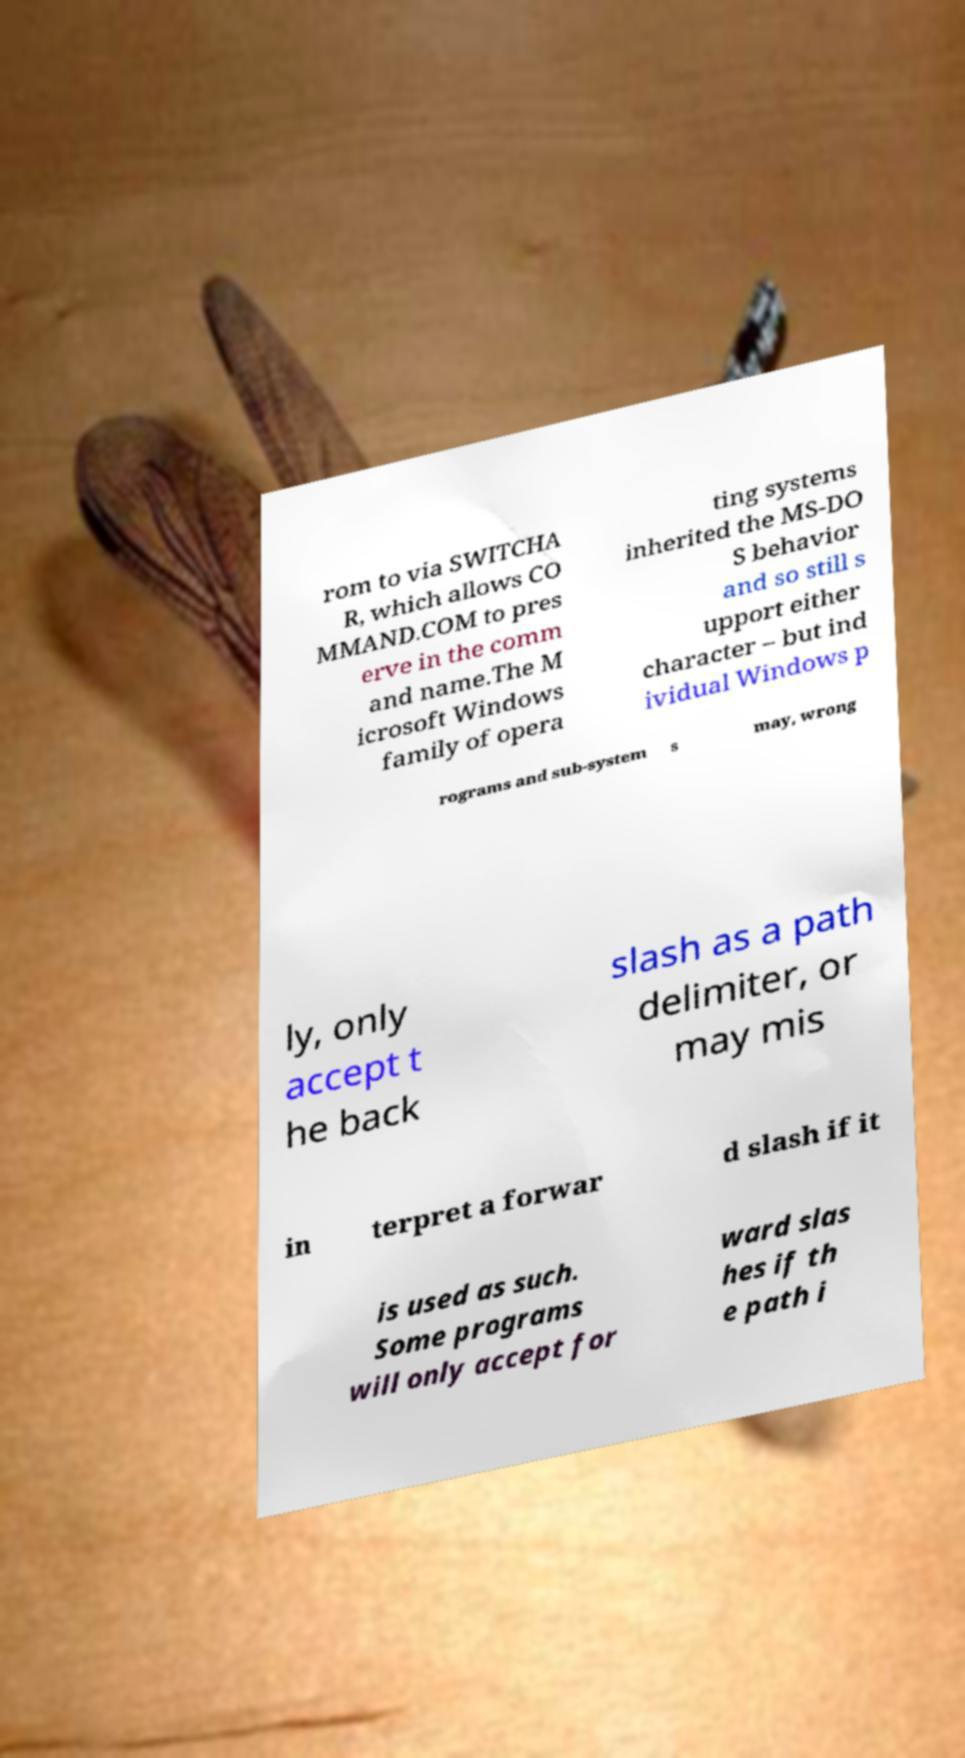Can you accurately transcribe the text from the provided image for me? rom to via SWITCHA R, which allows CO MMAND.COM to pres erve in the comm and name.The M icrosoft Windows family of opera ting systems inherited the MS-DO S behavior and so still s upport either character – but ind ividual Windows p rograms and sub-system s may, wrong ly, only accept t he back slash as a path delimiter, or may mis in terpret a forwar d slash if it is used as such. Some programs will only accept for ward slas hes if th e path i 